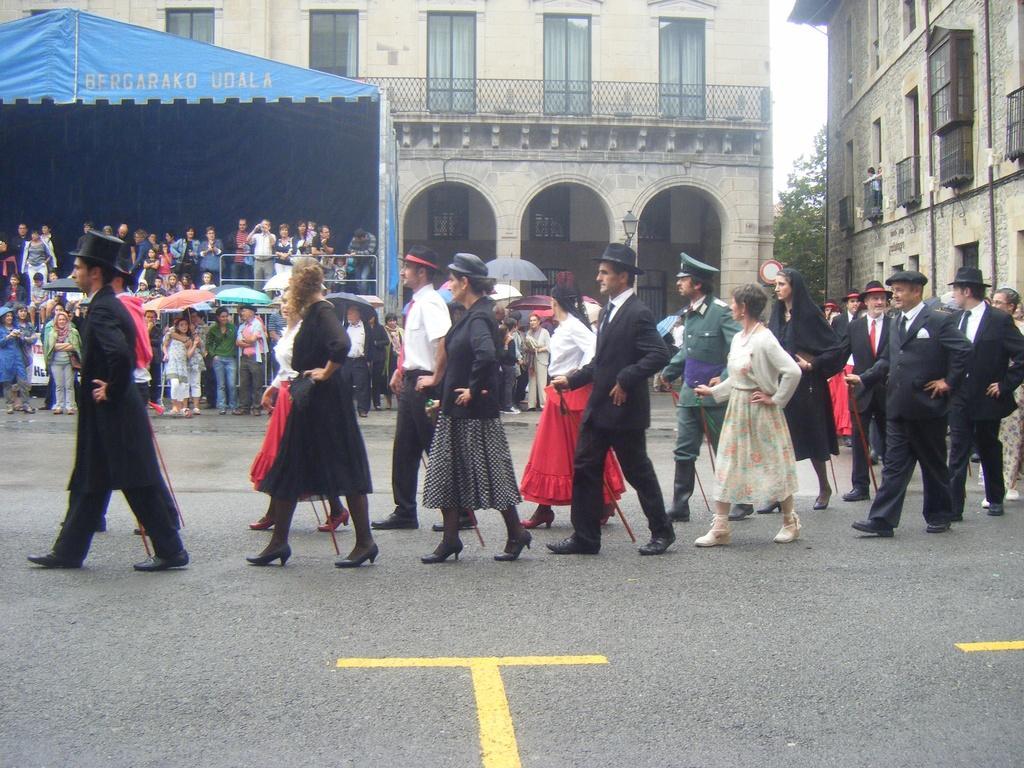In one or two sentences, can you explain what this image depicts? In the foreground of this image, there are persons walking and holding sticks on the road. In the background, there are persons, few are holding umbrellas and few are standing under the tent and we can also see two buildings, a tree and the sky. 